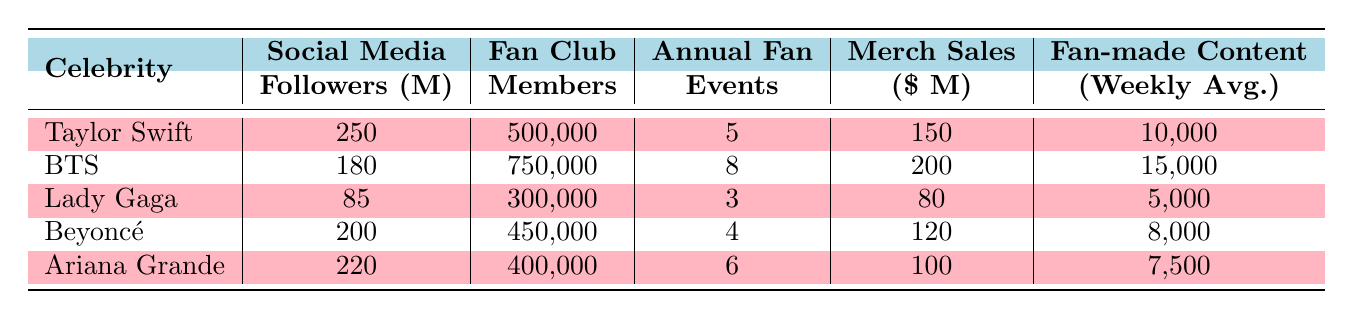What is the highest number of social media followers among the celebrities? Referring to the "Social Media Followers (millions)" column in the table, Taylor Swift has 250 million followers, which is more than any other celebrity listed.
Answer: 250 million Which celebrity has the most fan club members? In the "Fan Club Members" column, BTS has the highest number of members with 750,000.
Answer: BTS How many annual fan events does Ariana Grande organize? Looking at the "Annual Fan Events" column, Ariana Grande organizes 6 events.
Answer: 6 What is the difference in annual fan events between Taylor Swift and Lady Gaga? Taylor Swift has 5 events and Lady Gaga has 3 events. The difference is calculated as 5 - 3 = 2.
Answer: 2 What is the average merchandise sales across all celebrities? Adding the merchandise sales: 150 + 200 + 80 + 120 + 100 = 650 million. There are 5 celebrities, so the average is 650 / 5 = 130 million.
Answer: 130 million Is it true that Beyoncé has more fan-made content (weekly average) compared to Lady Gaga? Beyoncé has 8,000 in fan-made content averages while Lady Gaga has 5,000. Since 8,000 is greater than 5,000, the statement is true.
Answer: Yes Which celebrity has the lowest merchandise sales, and what is the figure? In the "Merch Sales ($ millions)" column, Lady Gaga has the lowest sales at 80 million.
Answer: Lady Gaga, 80 million If we consider social media followers and merchandise sales, which celebrity has the highest combined total? For Taylor Swift: 250 (followers) + 150 (sales) = 400; for BTS: 180 + 200 = 380; for Lady Gaga: 85 + 80 = 165; for Beyoncé: 200 + 120 = 320; for Ariana Grande: 220 + 100 = 320. Taylor Swift has the highest total of 400.
Answer: Taylor Swift, 400 What percentage of fan club members does Ariana Grande have compared to BTS? Ariana Grande has 400,000 members, and BTS has 750,000. The percentage is (400,000 / 750,000) * 100 = 53.33%.
Answer: 53.33% How many more annual fan events does BTS conduct compared to Beyoncé? BTS conducts 8 events and Beyoncé conducts 4 events. The difference is 8 - 4 = 4 events.
Answer: 4 events 